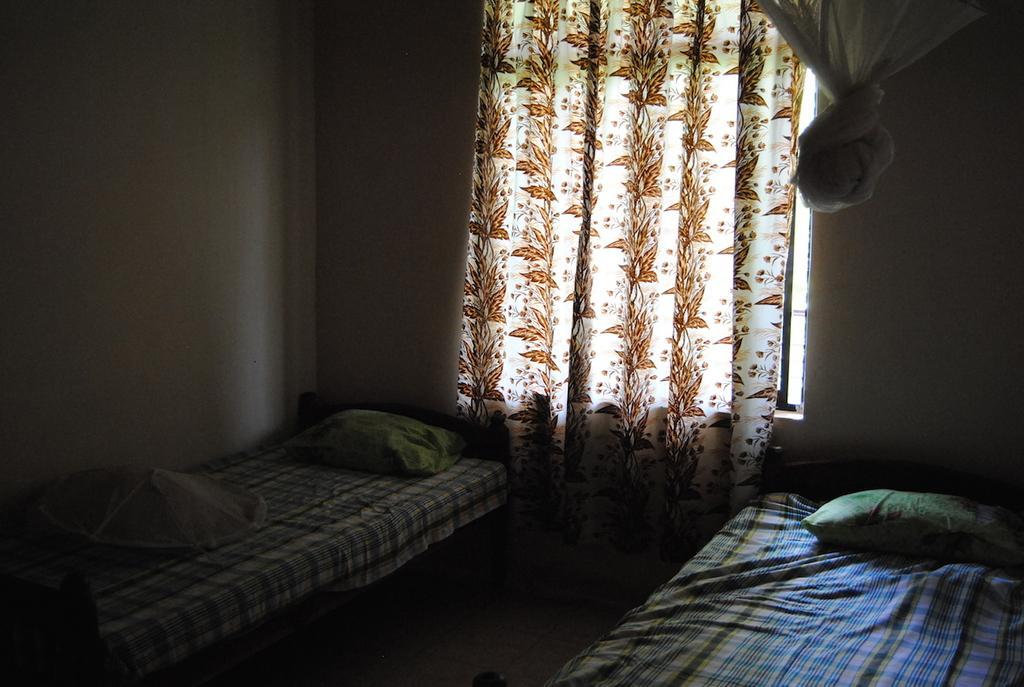Could you give a brief overview of what you see in this image? In this picture we can see there are two beds on the floor and on the beds there are pillows and behind the beds there is a wall with a curtain. 